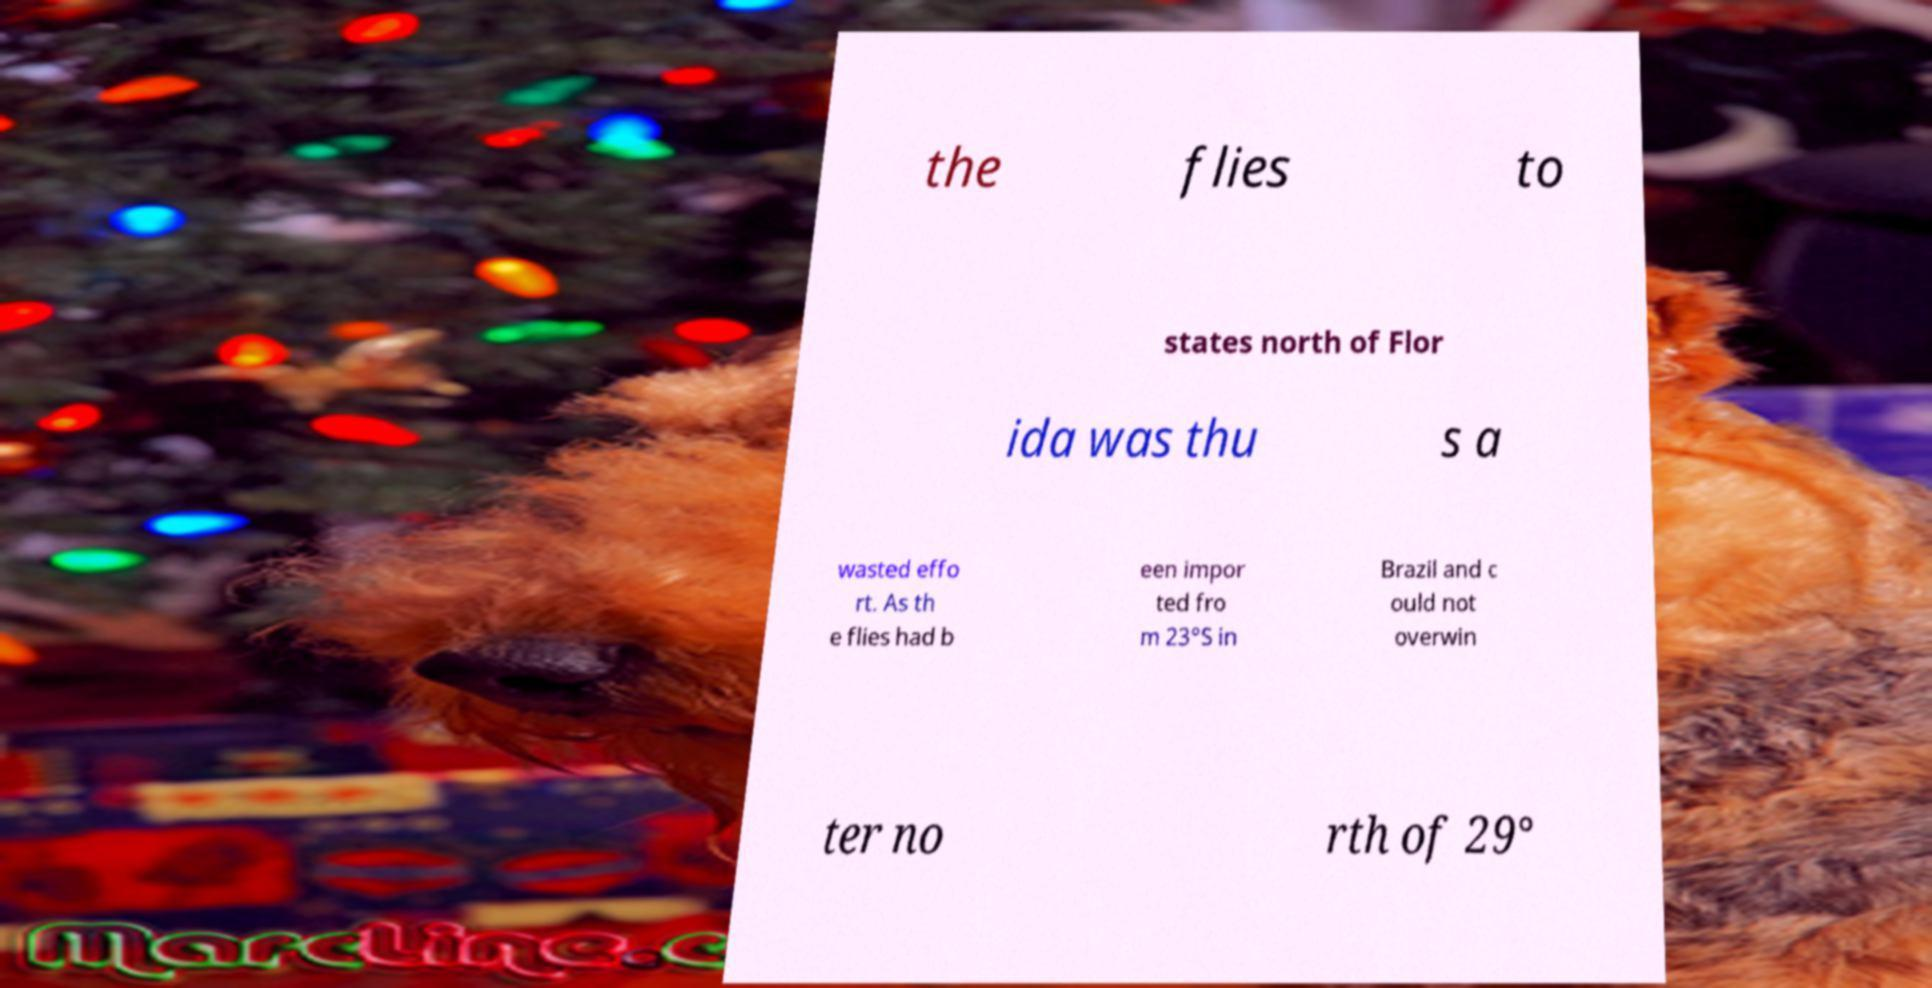Please read and relay the text visible in this image. What does it say? the flies to states north of Flor ida was thu s a wasted effo rt. As th e flies had b een impor ted fro m 23°S in Brazil and c ould not overwin ter no rth of 29° 